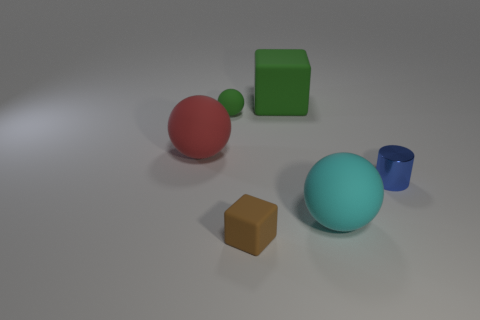Is there any other thing that is the same material as the big cyan thing?
Your answer should be compact. Yes. How many other objects are there of the same material as the small blue object?
Make the answer very short. 0. There is a rubber cube that is to the left of the block that is behind the tiny matte thing that is in front of the cyan rubber thing; what is its color?
Keep it short and to the point. Brown. What is the material of the green cube that is the same size as the cyan matte ball?
Ensure brevity in your answer.  Rubber. How many things are tiny matte things that are left of the tiny cube or small green matte spheres?
Your answer should be very brief. 1. Are there any small blue things?
Provide a short and direct response. Yes. There is a ball in front of the big red object; what is its material?
Your answer should be very brief. Rubber. There is a small ball that is the same color as the big rubber cube; what is its material?
Your answer should be very brief. Rubber. How many large objects are either cubes or shiny cylinders?
Your answer should be very brief. 1. The big matte block is what color?
Your response must be concise. Green. 